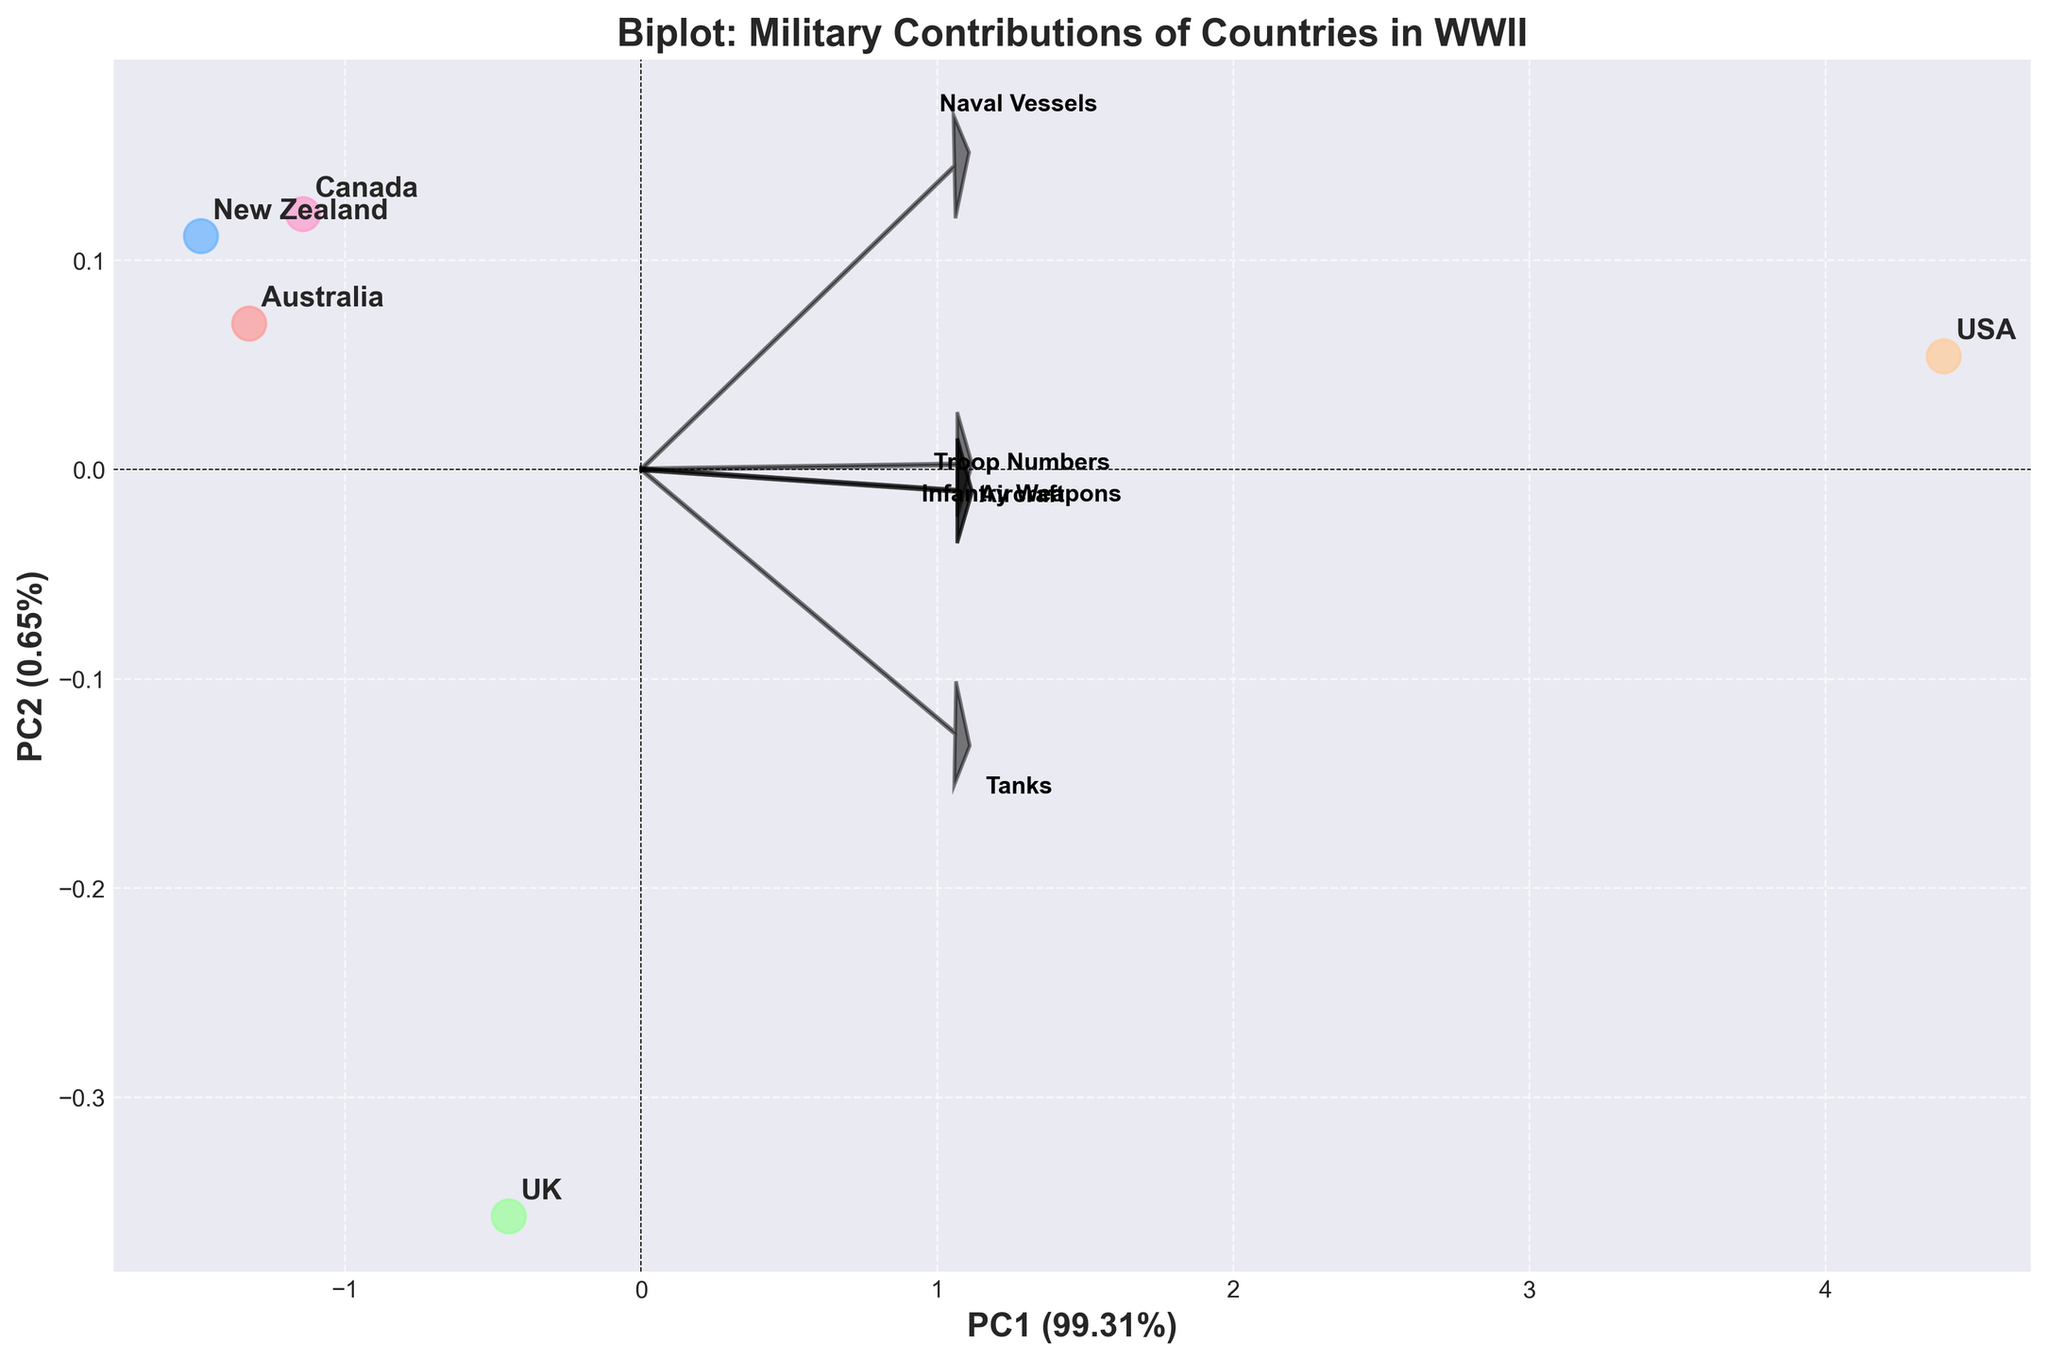What is the title of the plot? The title of the plot is given at the top of the figure. It reads "Biplot: Military Contributions of Countries in WWII"
Answer: Biplot: Military Contributions of Countries in WWII How many arrows representing features are shown on the plot? There are arrows representing different military contributions marked with labels like 'Tanks', 'Aircraft', etc. Counting these arrows gives us their total number.
Answer: 5 Which country is closest to the origin (0,0) in the plot? The point closest to the origin can be identified by looking at the scatter points and their distance from the (0,0) coordinates.
Answer: New Zealand Which country has the highest score on PC1? By examining the horizontal axis (PC1), the country with the rightmost point has the highest PC1 score.
Answer: USA Which two countries appear to be the most similar based on the biplot? Two countries that are closest to each other on the plot can be considered the most similar in terms of their military contributions. From the scatter plot locations, these countries can be identified.
Answer: Australia and Canada What feature contributes the most to the variation explained by PC1? By looking at the length and direction of the arrows in the direction of the PC1 axis (horizontal), the feature with the longest arrow in this direction has the most significant contribution.
Answer: Troop Numbers Which country has the least number of naval vessels, based on their position and the corresponding feature contribution? By comparing the naval vessels arrow direction and length with the position of the countries, we see which point aligns least along this variable.
Answer: New Zealand Rank the countries in descending order based on their PC1 scores. Countries are ranked by their horizontal positions, with those further right having higher PC1 scores. From right to left: USA, UK, Canada, Australia, New Zealand.
Answer: USA, UK, Canada, Australia, New Zealand What percent of the variation is explained by PC2? The label for the PC2 axis contains the explained variance percentage for PC2.
Answer: Approximately 15.76% 